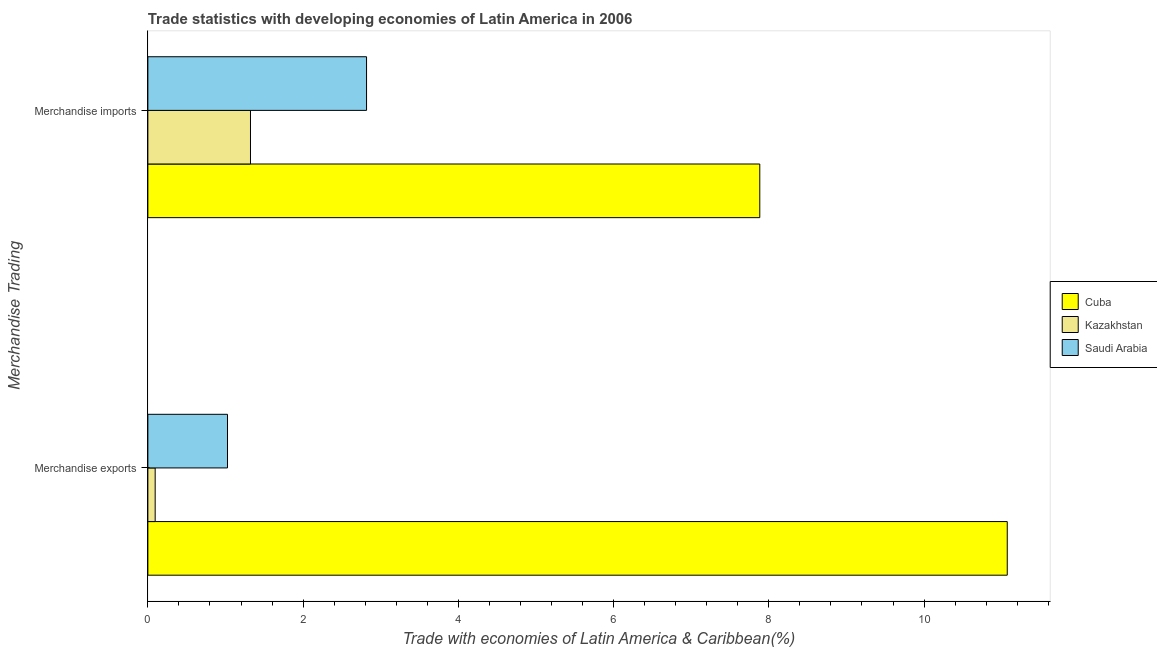How many groups of bars are there?
Keep it short and to the point. 2. Are the number of bars per tick equal to the number of legend labels?
Offer a terse response. Yes. How many bars are there on the 1st tick from the bottom?
Offer a terse response. 3. What is the label of the 1st group of bars from the top?
Keep it short and to the point. Merchandise imports. What is the merchandise imports in Kazakhstan?
Give a very brief answer. 1.32. Across all countries, what is the maximum merchandise imports?
Your answer should be very brief. 7.88. Across all countries, what is the minimum merchandise imports?
Your answer should be compact. 1.32. In which country was the merchandise exports maximum?
Your answer should be compact. Cuba. In which country was the merchandise imports minimum?
Provide a succinct answer. Kazakhstan. What is the total merchandise exports in the graph?
Your response must be concise. 12.19. What is the difference between the merchandise exports in Saudi Arabia and that in Kazakhstan?
Make the answer very short. 0.93. What is the difference between the merchandise exports in Saudi Arabia and the merchandise imports in Kazakhstan?
Ensure brevity in your answer.  -0.3. What is the average merchandise exports per country?
Give a very brief answer. 4.06. What is the difference between the merchandise exports and merchandise imports in Saudi Arabia?
Give a very brief answer. -1.79. What is the ratio of the merchandise imports in Kazakhstan to that in Saudi Arabia?
Offer a terse response. 0.47. In how many countries, is the merchandise exports greater than the average merchandise exports taken over all countries?
Ensure brevity in your answer.  1. What does the 3rd bar from the top in Merchandise exports represents?
Your answer should be compact. Cuba. What does the 2nd bar from the bottom in Merchandise imports represents?
Ensure brevity in your answer.  Kazakhstan. Are all the bars in the graph horizontal?
Provide a succinct answer. Yes. How many countries are there in the graph?
Offer a terse response. 3. What is the difference between two consecutive major ticks on the X-axis?
Make the answer very short. 2. Does the graph contain any zero values?
Offer a terse response. No. Does the graph contain grids?
Provide a succinct answer. No. Where does the legend appear in the graph?
Your response must be concise. Center right. What is the title of the graph?
Keep it short and to the point. Trade statistics with developing economies of Latin America in 2006. What is the label or title of the X-axis?
Offer a terse response. Trade with economies of Latin America & Caribbean(%). What is the label or title of the Y-axis?
Ensure brevity in your answer.  Merchandise Trading. What is the Trade with economies of Latin America & Caribbean(%) of Cuba in Merchandise exports?
Provide a succinct answer. 11.07. What is the Trade with economies of Latin America & Caribbean(%) in Kazakhstan in Merchandise exports?
Give a very brief answer. 0.09. What is the Trade with economies of Latin America & Caribbean(%) of Saudi Arabia in Merchandise exports?
Offer a terse response. 1.03. What is the Trade with economies of Latin America & Caribbean(%) of Cuba in Merchandise imports?
Ensure brevity in your answer.  7.88. What is the Trade with economies of Latin America & Caribbean(%) of Kazakhstan in Merchandise imports?
Your response must be concise. 1.32. What is the Trade with economies of Latin America & Caribbean(%) of Saudi Arabia in Merchandise imports?
Make the answer very short. 2.82. Across all Merchandise Trading, what is the maximum Trade with economies of Latin America & Caribbean(%) in Cuba?
Offer a very short reply. 11.07. Across all Merchandise Trading, what is the maximum Trade with economies of Latin America & Caribbean(%) of Kazakhstan?
Keep it short and to the point. 1.32. Across all Merchandise Trading, what is the maximum Trade with economies of Latin America & Caribbean(%) of Saudi Arabia?
Ensure brevity in your answer.  2.82. Across all Merchandise Trading, what is the minimum Trade with economies of Latin America & Caribbean(%) of Cuba?
Your answer should be compact. 7.88. Across all Merchandise Trading, what is the minimum Trade with economies of Latin America & Caribbean(%) of Kazakhstan?
Your answer should be very brief. 0.09. Across all Merchandise Trading, what is the minimum Trade with economies of Latin America & Caribbean(%) of Saudi Arabia?
Your answer should be compact. 1.03. What is the total Trade with economies of Latin America & Caribbean(%) in Cuba in the graph?
Offer a very short reply. 18.95. What is the total Trade with economies of Latin America & Caribbean(%) of Kazakhstan in the graph?
Offer a terse response. 1.42. What is the total Trade with economies of Latin America & Caribbean(%) of Saudi Arabia in the graph?
Your answer should be compact. 3.84. What is the difference between the Trade with economies of Latin America & Caribbean(%) in Cuba in Merchandise exports and that in Merchandise imports?
Provide a short and direct response. 3.19. What is the difference between the Trade with economies of Latin America & Caribbean(%) in Kazakhstan in Merchandise exports and that in Merchandise imports?
Give a very brief answer. -1.23. What is the difference between the Trade with economies of Latin America & Caribbean(%) of Saudi Arabia in Merchandise exports and that in Merchandise imports?
Ensure brevity in your answer.  -1.79. What is the difference between the Trade with economies of Latin America & Caribbean(%) in Cuba in Merchandise exports and the Trade with economies of Latin America & Caribbean(%) in Kazakhstan in Merchandise imports?
Provide a succinct answer. 9.75. What is the difference between the Trade with economies of Latin America & Caribbean(%) of Cuba in Merchandise exports and the Trade with economies of Latin America & Caribbean(%) of Saudi Arabia in Merchandise imports?
Make the answer very short. 8.25. What is the difference between the Trade with economies of Latin America & Caribbean(%) of Kazakhstan in Merchandise exports and the Trade with economies of Latin America & Caribbean(%) of Saudi Arabia in Merchandise imports?
Give a very brief answer. -2.72. What is the average Trade with economies of Latin America & Caribbean(%) in Cuba per Merchandise Trading?
Give a very brief answer. 9.48. What is the average Trade with economies of Latin America & Caribbean(%) in Kazakhstan per Merchandise Trading?
Give a very brief answer. 0.71. What is the average Trade with economies of Latin America & Caribbean(%) in Saudi Arabia per Merchandise Trading?
Make the answer very short. 1.92. What is the difference between the Trade with economies of Latin America & Caribbean(%) of Cuba and Trade with economies of Latin America & Caribbean(%) of Kazakhstan in Merchandise exports?
Give a very brief answer. 10.98. What is the difference between the Trade with economies of Latin America & Caribbean(%) in Cuba and Trade with economies of Latin America & Caribbean(%) in Saudi Arabia in Merchandise exports?
Your answer should be compact. 10.05. What is the difference between the Trade with economies of Latin America & Caribbean(%) in Kazakhstan and Trade with economies of Latin America & Caribbean(%) in Saudi Arabia in Merchandise exports?
Make the answer very short. -0.93. What is the difference between the Trade with economies of Latin America & Caribbean(%) of Cuba and Trade with economies of Latin America & Caribbean(%) of Kazakhstan in Merchandise imports?
Your answer should be compact. 6.56. What is the difference between the Trade with economies of Latin America & Caribbean(%) of Cuba and Trade with economies of Latin America & Caribbean(%) of Saudi Arabia in Merchandise imports?
Give a very brief answer. 5.07. What is the difference between the Trade with economies of Latin America & Caribbean(%) in Kazakhstan and Trade with economies of Latin America & Caribbean(%) in Saudi Arabia in Merchandise imports?
Your response must be concise. -1.5. What is the ratio of the Trade with economies of Latin America & Caribbean(%) in Cuba in Merchandise exports to that in Merchandise imports?
Give a very brief answer. 1.4. What is the ratio of the Trade with economies of Latin America & Caribbean(%) in Kazakhstan in Merchandise exports to that in Merchandise imports?
Provide a succinct answer. 0.07. What is the ratio of the Trade with economies of Latin America & Caribbean(%) in Saudi Arabia in Merchandise exports to that in Merchandise imports?
Your response must be concise. 0.36. What is the difference between the highest and the second highest Trade with economies of Latin America & Caribbean(%) in Cuba?
Your response must be concise. 3.19. What is the difference between the highest and the second highest Trade with economies of Latin America & Caribbean(%) of Kazakhstan?
Offer a terse response. 1.23. What is the difference between the highest and the second highest Trade with economies of Latin America & Caribbean(%) in Saudi Arabia?
Keep it short and to the point. 1.79. What is the difference between the highest and the lowest Trade with economies of Latin America & Caribbean(%) in Cuba?
Offer a very short reply. 3.19. What is the difference between the highest and the lowest Trade with economies of Latin America & Caribbean(%) in Kazakhstan?
Provide a succinct answer. 1.23. What is the difference between the highest and the lowest Trade with economies of Latin America & Caribbean(%) in Saudi Arabia?
Your response must be concise. 1.79. 